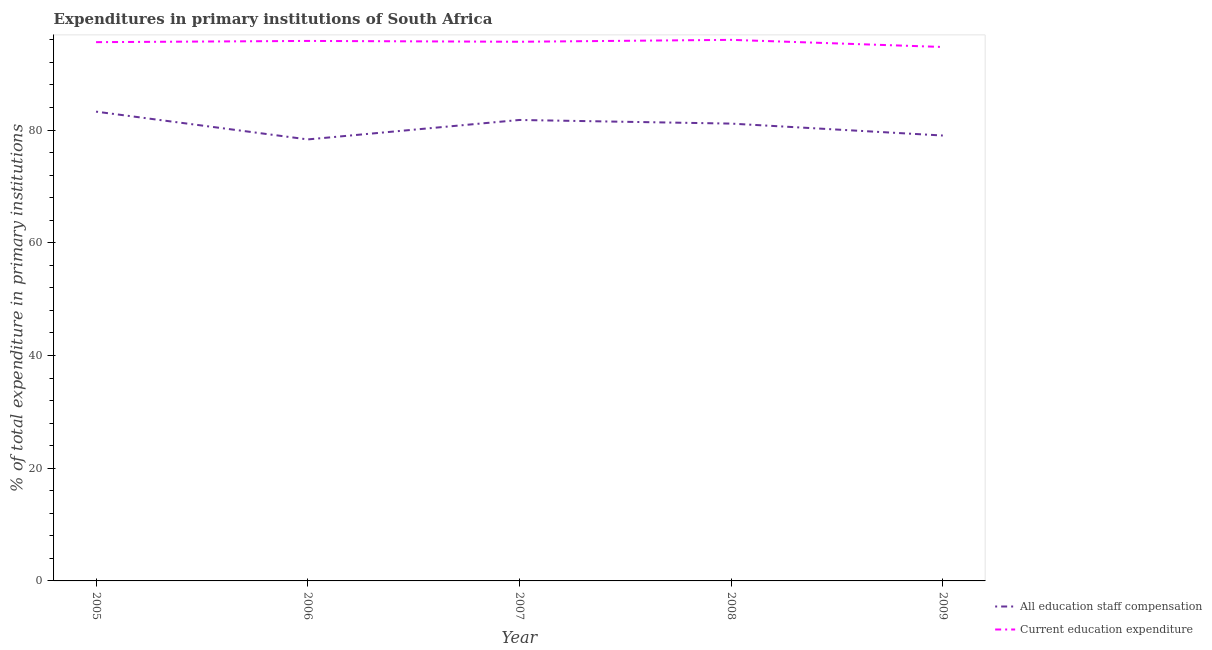Does the line corresponding to expenditure in education intersect with the line corresponding to expenditure in staff compensation?
Keep it short and to the point. No. Is the number of lines equal to the number of legend labels?
Your answer should be very brief. Yes. What is the expenditure in staff compensation in 2008?
Your answer should be compact. 81.14. Across all years, what is the maximum expenditure in staff compensation?
Ensure brevity in your answer.  83.27. Across all years, what is the minimum expenditure in staff compensation?
Give a very brief answer. 78.33. In which year was the expenditure in education maximum?
Keep it short and to the point. 2008. In which year was the expenditure in education minimum?
Offer a very short reply. 2009. What is the total expenditure in staff compensation in the graph?
Provide a succinct answer. 403.55. What is the difference between the expenditure in staff compensation in 2007 and that in 2009?
Keep it short and to the point. 2.76. What is the difference between the expenditure in staff compensation in 2006 and the expenditure in education in 2008?
Offer a very short reply. -17.67. What is the average expenditure in staff compensation per year?
Your response must be concise. 80.71. In the year 2008, what is the difference between the expenditure in education and expenditure in staff compensation?
Give a very brief answer. 14.86. What is the ratio of the expenditure in education in 2007 to that in 2009?
Give a very brief answer. 1.01. Is the expenditure in staff compensation in 2006 less than that in 2008?
Offer a very short reply. Yes. Is the difference between the expenditure in education in 2006 and 2009 greater than the difference between the expenditure in staff compensation in 2006 and 2009?
Give a very brief answer. Yes. What is the difference between the highest and the second highest expenditure in staff compensation?
Offer a very short reply. 1.48. What is the difference between the highest and the lowest expenditure in education?
Keep it short and to the point. 1.27. In how many years, is the expenditure in staff compensation greater than the average expenditure in staff compensation taken over all years?
Your answer should be compact. 3. Is the sum of the expenditure in staff compensation in 2005 and 2006 greater than the maximum expenditure in education across all years?
Provide a succinct answer. Yes. Is the expenditure in staff compensation strictly greater than the expenditure in education over the years?
Your response must be concise. No. Does the graph contain grids?
Your answer should be very brief. No. Where does the legend appear in the graph?
Ensure brevity in your answer.  Bottom right. How are the legend labels stacked?
Keep it short and to the point. Vertical. What is the title of the graph?
Provide a short and direct response. Expenditures in primary institutions of South Africa. Does "Malaria" appear as one of the legend labels in the graph?
Your answer should be compact. No. What is the label or title of the X-axis?
Provide a succinct answer. Year. What is the label or title of the Y-axis?
Offer a terse response. % of total expenditure in primary institutions. What is the % of total expenditure in primary institutions in All education staff compensation in 2005?
Give a very brief answer. 83.27. What is the % of total expenditure in primary institutions of Current education expenditure in 2005?
Make the answer very short. 95.59. What is the % of total expenditure in primary institutions in All education staff compensation in 2006?
Offer a very short reply. 78.33. What is the % of total expenditure in primary institutions in Current education expenditure in 2006?
Offer a very short reply. 95.81. What is the % of total expenditure in primary institutions in All education staff compensation in 2007?
Your response must be concise. 81.79. What is the % of total expenditure in primary institutions of Current education expenditure in 2007?
Provide a succinct answer. 95.66. What is the % of total expenditure in primary institutions in All education staff compensation in 2008?
Give a very brief answer. 81.14. What is the % of total expenditure in primary institutions in Current education expenditure in 2008?
Your answer should be very brief. 96. What is the % of total expenditure in primary institutions of All education staff compensation in 2009?
Provide a short and direct response. 79.03. What is the % of total expenditure in primary institutions of Current education expenditure in 2009?
Provide a short and direct response. 94.73. Across all years, what is the maximum % of total expenditure in primary institutions in All education staff compensation?
Ensure brevity in your answer.  83.27. Across all years, what is the maximum % of total expenditure in primary institutions of Current education expenditure?
Provide a succinct answer. 96. Across all years, what is the minimum % of total expenditure in primary institutions in All education staff compensation?
Your answer should be very brief. 78.33. Across all years, what is the minimum % of total expenditure in primary institutions of Current education expenditure?
Offer a terse response. 94.73. What is the total % of total expenditure in primary institutions in All education staff compensation in the graph?
Your answer should be very brief. 403.55. What is the total % of total expenditure in primary institutions of Current education expenditure in the graph?
Offer a very short reply. 477.8. What is the difference between the % of total expenditure in primary institutions in All education staff compensation in 2005 and that in 2006?
Your response must be concise. 4.93. What is the difference between the % of total expenditure in primary institutions of Current education expenditure in 2005 and that in 2006?
Keep it short and to the point. -0.22. What is the difference between the % of total expenditure in primary institutions of All education staff compensation in 2005 and that in 2007?
Give a very brief answer. 1.48. What is the difference between the % of total expenditure in primary institutions in Current education expenditure in 2005 and that in 2007?
Your answer should be very brief. -0.07. What is the difference between the % of total expenditure in primary institutions in All education staff compensation in 2005 and that in 2008?
Keep it short and to the point. 2.12. What is the difference between the % of total expenditure in primary institutions in Current education expenditure in 2005 and that in 2008?
Your answer should be very brief. -0.41. What is the difference between the % of total expenditure in primary institutions in All education staff compensation in 2005 and that in 2009?
Your answer should be very brief. 4.24. What is the difference between the % of total expenditure in primary institutions in Current education expenditure in 2005 and that in 2009?
Provide a short and direct response. 0.86. What is the difference between the % of total expenditure in primary institutions in All education staff compensation in 2006 and that in 2007?
Give a very brief answer. -3.45. What is the difference between the % of total expenditure in primary institutions of Current education expenditure in 2006 and that in 2007?
Your answer should be very brief. 0.15. What is the difference between the % of total expenditure in primary institutions in All education staff compensation in 2006 and that in 2008?
Offer a terse response. -2.81. What is the difference between the % of total expenditure in primary institutions of Current education expenditure in 2006 and that in 2008?
Ensure brevity in your answer.  -0.19. What is the difference between the % of total expenditure in primary institutions of All education staff compensation in 2006 and that in 2009?
Ensure brevity in your answer.  -0.69. What is the difference between the % of total expenditure in primary institutions in Current education expenditure in 2006 and that in 2009?
Keep it short and to the point. 1.08. What is the difference between the % of total expenditure in primary institutions of All education staff compensation in 2007 and that in 2008?
Offer a very short reply. 0.64. What is the difference between the % of total expenditure in primary institutions in Current education expenditure in 2007 and that in 2008?
Provide a succinct answer. -0.34. What is the difference between the % of total expenditure in primary institutions of All education staff compensation in 2007 and that in 2009?
Ensure brevity in your answer.  2.76. What is the difference between the % of total expenditure in primary institutions in Current education expenditure in 2007 and that in 2009?
Your answer should be compact. 0.93. What is the difference between the % of total expenditure in primary institutions in All education staff compensation in 2008 and that in 2009?
Give a very brief answer. 2.12. What is the difference between the % of total expenditure in primary institutions of Current education expenditure in 2008 and that in 2009?
Your answer should be compact. 1.27. What is the difference between the % of total expenditure in primary institutions of All education staff compensation in 2005 and the % of total expenditure in primary institutions of Current education expenditure in 2006?
Your response must be concise. -12.54. What is the difference between the % of total expenditure in primary institutions of All education staff compensation in 2005 and the % of total expenditure in primary institutions of Current education expenditure in 2007?
Your answer should be very brief. -12.4. What is the difference between the % of total expenditure in primary institutions of All education staff compensation in 2005 and the % of total expenditure in primary institutions of Current education expenditure in 2008?
Make the answer very short. -12.73. What is the difference between the % of total expenditure in primary institutions of All education staff compensation in 2005 and the % of total expenditure in primary institutions of Current education expenditure in 2009?
Keep it short and to the point. -11.47. What is the difference between the % of total expenditure in primary institutions in All education staff compensation in 2006 and the % of total expenditure in primary institutions in Current education expenditure in 2007?
Give a very brief answer. -17.33. What is the difference between the % of total expenditure in primary institutions of All education staff compensation in 2006 and the % of total expenditure in primary institutions of Current education expenditure in 2008?
Keep it short and to the point. -17.67. What is the difference between the % of total expenditure in primary institutions of All education staff compensation in 2006 and the % of total expenditure in primary institutions of Current education expenditure in 2009?
Your response must be concise. -16.4. What is the difference between the % of total expenditure in primary institutions in All education staff compensation in 2007 and the % of total expenditure in primary institutions in Current education expenditure in 2008?
Offer a terse response. -14.21. What is the difference between the % of total expenditure in primary institutions of All education staff compensation in 2007 and the % of total expenditure in primary institutions of Current education expenditure in 2009?
Your response must be concise. -12.95. What is the difference between the % of total expenditure in primary institutions of All education staff compensation in 2008 and the % of total expenditure in primary institutions of Current education expenditure in 2009?
Provide a short and direct response. -13.59. What is the average % of total expenditure in primary institutions of All education staff compensation per year?
Provide a succinct answer. 80.71. What is the average % of total expenditure in primary institutions of Current education expenditure per year?
Offer a terse response. 95.56. In the year 2005, what is the difference between the % of total expenditure in primary institutions in All education staff compensation and % of total expenditure in primary institutions in Current education expenditure?
Keep it short and to the point. -12.33. In the year 2006, what is the difference between the % of total expenditure in primary institutions in All education staff compensation and % of total expenditure in primary institutions in Current education expenditure?
Make the answer very short. -17.47. In the year 2007, what is the difference between the % of total expenditure in primary institutions of All education staff compensation and % of total expenditure in primary institutions of Current education expenditure?
Give a very brief answer. -13.88. In the year 2008, what is the difference between the % of total expenditure in primary institutions in All education staff compensation and % of total expenditure in primary institutions in Current education expenditure?
Your answer should be compact. -14.86. In the year 2009, what is the difference between the % of total expenditure in primary institutions of All education staff compensation and % of total expenditure in primary institutions of Current education expenditure?
Give a very brief answer. -15.71. What is the ratio of the % of total expenditure in primary institutions in All education staff compensation in 2005 to that in 2006?
Offer a very short reply. 1.06. What is the ratio of the % of total expenditure in primary institutions in All education staff compensation in 2005 to that in 2007?
Provide a short and direct response. 1.02. What is the ratio of the % of total expenditure in primary institutions in Current education expenditure in 2005 to that in 2007?
Offer a terse response. 1. What is the ratio of the % of total expenditure in primary institutions of All education staff compensation in 2005 to that in 2008?
Your answer should be very brief. 1.03. What is the ratio of the % of total expenditure in primary institutions in Current education expenditure in 2005 to that in 2008?
Your answer should be very brief. 1. What is the ratio of the % of total expenditure in primary institutions of All education staff compensation in 2005 to that in 2009?
Ensure brevity in your answer.  1.05. What is the ratio of the % of total expenditure in primary institutions of Current education expenditure in 2005 to that in 2009?
Provide a short and direct response. 1.01. What is the ratio of the % of total expenditure in primary institutions of All education staff compensation in 2006 to that in 2007?
Keep it short and to the point. 0.96. What is the ratio of the % of total expenditure in primary institutions in Current education expenditure in 2006 to that in 2007?
Keep it short and to the point. 1. What is the ratio of the % of total expenditure in primary institutions in All education staff compensation in 2006 to that in 2008?
Ensure brevity in your answer.  0.97. What is the ratio of the % of total expenditure in primary institutions in Current education expenditure in 2006 to that in 2008?
Your response must be concise. 1. What is the ratio of the % of total expenditure in primary institutions of Current education expenditure in 2006 to that in 2009?
Give a very brief answer. 1.01. What is the ratio of the % of total expenditure in primary institutions of All education staff compensation in 2007 to that in 2008?
Offer a very short reply. 1.01. What is the ratio of the % of total expenditure in primary institutions in All education staff compensation in 2007 to that in 2009?
Offer a terse response. 1.03. What is the ratio of the % of total expenditure in primary institutions in Current education expenditure in 2007 to that in 2009?
Offer a very short reply. 1.01. What is the ratio of the % of total expenditure in primary institutions in All education staff compensation in 2008 to that in 2009?
Provide a short and direct response. 1.03. What is the ratio of the % of total expenditure in primary institutions of Current education expenditure in 2008 to that in 2009?
Offer a very short reply. 1.01. What is the difference between the highest and the second highest % of total expenditure in primary institutions in All education staff compensation?
Provide a short and direct response. 1.48. What is the difference between the highest and the second highest % of total expenditure in primary institutions of Current education expenditure?
Your answer should be very brief. 0.19. What is the difference between the highest and the lowest % of total expenditure in primary institutions of All education staff compensation?
Make the answer very short. 4.93. What is the difference between the highest and the lowest % of total expenditure in primary institutions of Current education expenditure?
Ensure brevity in your answer.  1.27. 